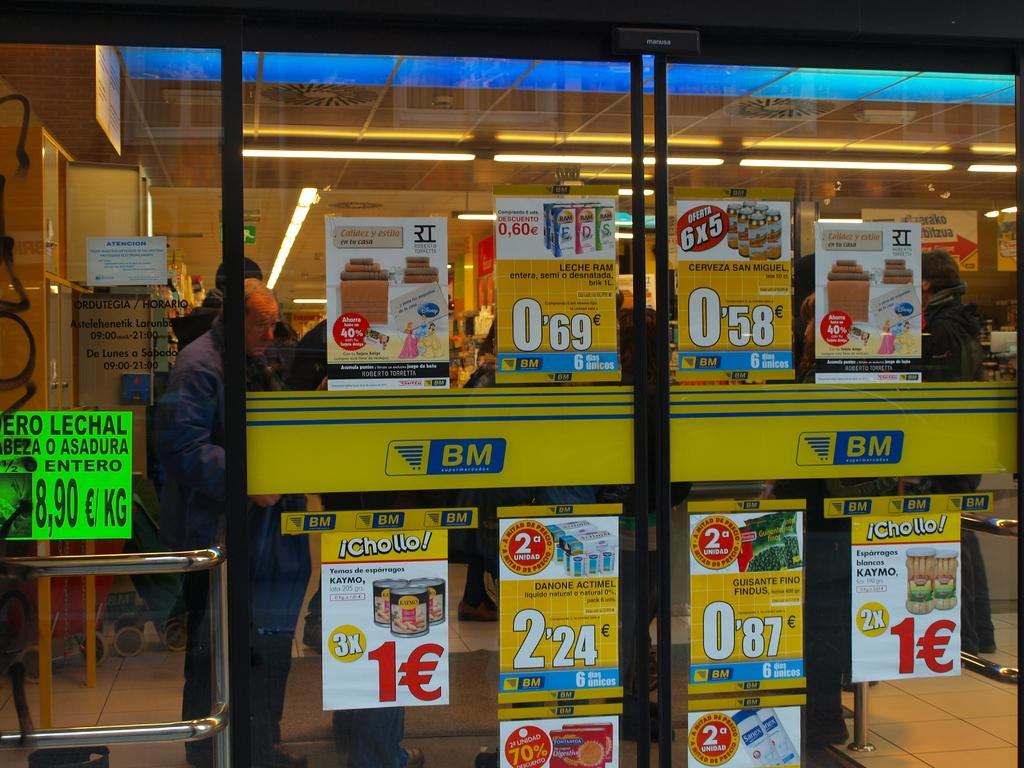<image>
Write a terse but informative summary of the picture. a lot of sales are going on at the store BM 